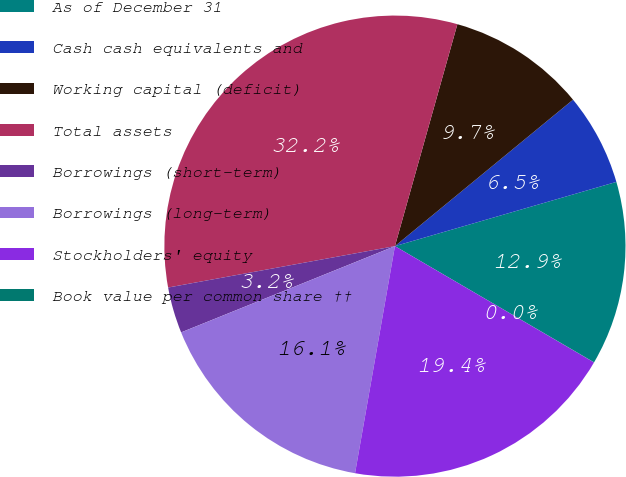Convert chart. <chart><loc_0><loc_0><loc_500><loc_500><pie_chart><fcel>As of December 31<fcel>Cash cash equivalents and<fcel>Working capital (deficit)<fcel>Total assets<fcel>Borrowings (short-term)<fcel>Borrowings (long-term)<fcel>Stockholders' equity<fcel>Book value per common share ††<nl><fcel>12.9%<fcel>6.46%<fcel>9.68%<fcel>32.24%<fcel>3.23%<fcel>16.13%<fcel>19.35%<fcel>0.01%<nl></chart> 